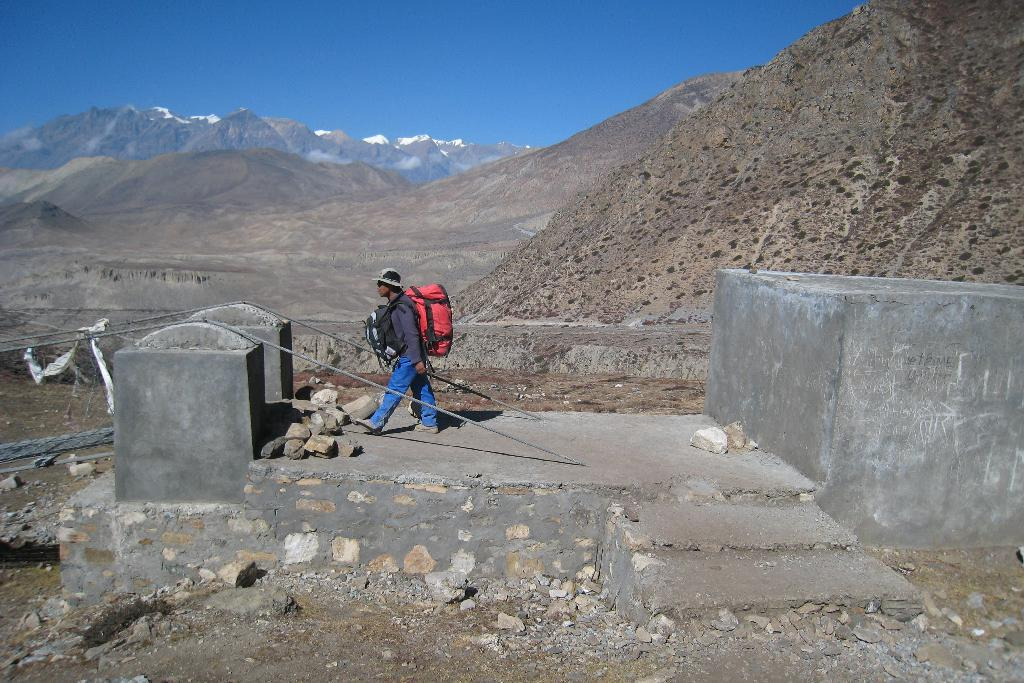What is the person in the image doing? There is a person walking in the image. What is the person wearing? The person is wearing a jersey. On what surface is the person walking? The person is walking on a floor. What can be seen on the left side of the image? There appears to be a cable bridge on the left side of the image. What type of landscape is visible in the background of the image? There are hills visible in the background of the image. What is visible at the top of the image? The sky is visible in the image. What type of crown is the person wearing in the image? There is no crown present in the image; the person is wearing a jersey. What color is the ink used to write on the person's jersey in the image? There is no writing or ink visible on the person's jersey in the image. 